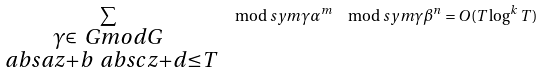<formula> <loc_0><loc_0><loc_500><loc_500>\sum _ { \substack { \gamma \in \ G m o d G \\ \ a b s { a z + b } \ a b s { c z + d } \leq T } } \mod s y m { \gamma } { \alpha } ^ { m } \mod s y m { \gamma } { \beta } ^ { n } & = O ( T \log ^ { k } T ) &</formula> 